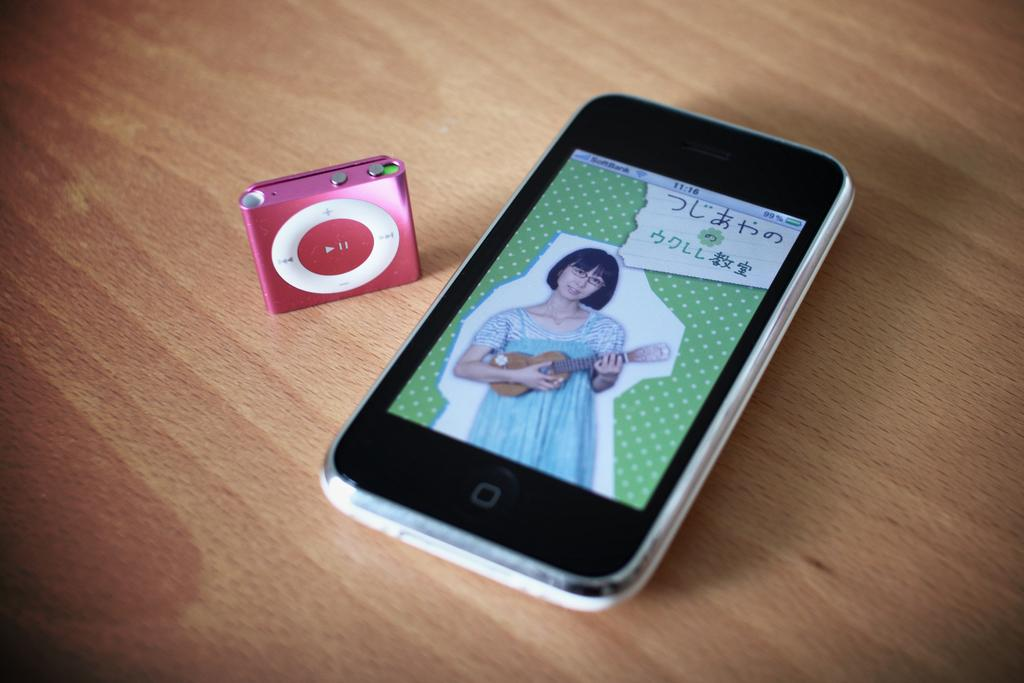What electronic device is visible in the image? There is an iPad in the image. What other object can be seen in the image? There is a mobile in the image. What type of animal is depicted in the plot of the image? There is no plot or animal present in the image; it features a mobile and an iPad. 